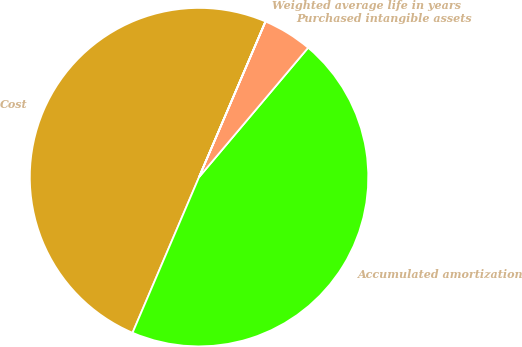<chart> <loc_0><loc_0><loc_500><loc_500><pie_chart><fcel>Cost<fcel>Accumulated amortization<fcel>Purchased intangible assets<fcel>Weighted average life in years<nl><fcel>49.99%<fcel>45.28%<fcel>4.72%<fcel>0.01%<nl></chart> 